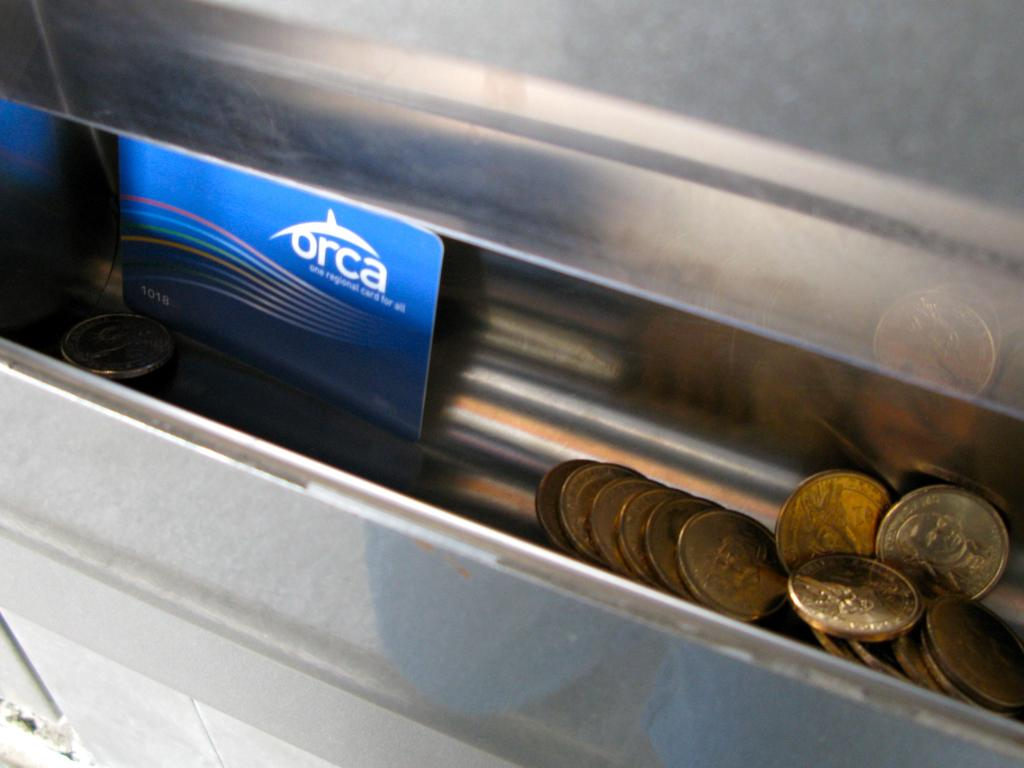<image>
Share a concise interpretation of the image provided. a change slot with pennies in it next to a card that says 'orca' on it 